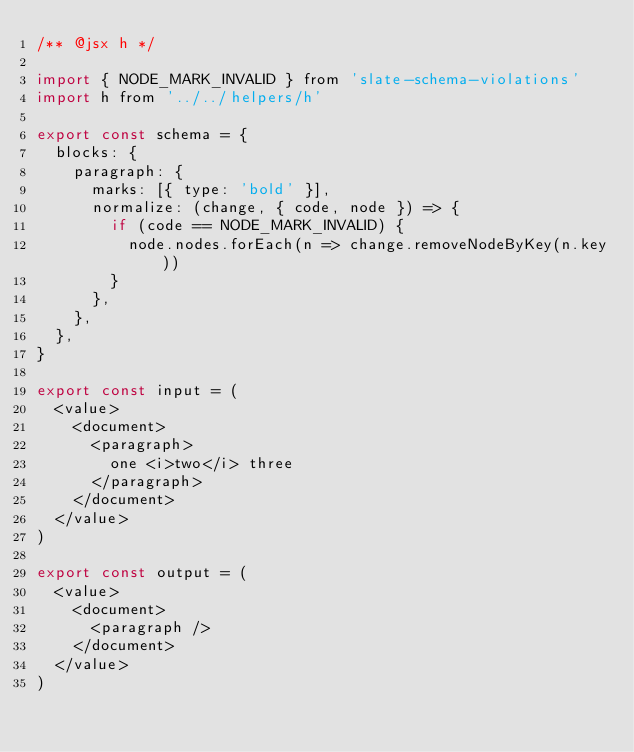Convert code to text. <code><loc_0><loc_0><loc_500><loc_500><_JavaScript_>/** @jsx h */

import { NODE_MARK_INVALID } from 'slate-schema-violations'
import h from '../../helpers/h'

export const schema = {
  blocks: {
    paragraph: {
      marks: [{ type: 'bold' }],
      normalize: (change, { code, node }) => {
        if (code == NODE_MARK_INVALID) {
          node.nodes.forEach(n => change.removeNodeByKey(n.key))
        }
      },
    },
  },
}

export const input = (
  <value>
    <document>
      <paragraph>
        one <i>two</i> three
      </paragraph>
    </document>
  </value>
)

export const output = (
  <value>
    <document>
      <paragraph />
    </document>
  </value>
)
</code> 